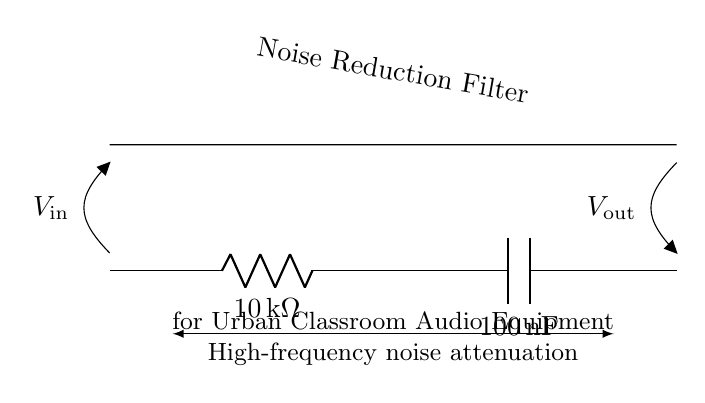What is the resistance value in the circuit? The resistance is written next to the resistor symbol and is noted as 10 kilohms in the circuit diagram.
Answer: 10 kilohms What component is labeled as C1? C1 is labeled as a capacitor, which is indicated in the diagram and has a specific capacitance value listed next to it.
Answer: Capacitor What does V_in represent in this circuit? V_in represents the input voltage; it's indicated at the starting point of the circuit where the input signal would enter.
Answer: Input voltage How does this circuit affect high-frequency noise? This circuit is designed to attenuate high-frequency noise, as shown by the label that describes the function between the resistor and capacitor components.
Answer: Attenuates high-frequency noise What is the system type represented by this circuit? The circuit type is a low-pass filter made by combining a resistor and a capacitor, which is specifically used for allowing low-frequency signals to pass while blocking higher frequencies.
Answer: Low-pass filter What happens to signals above the cutoff frequency in this filter? Signals above the cutoff frequency are significantly reduced in amplitude due to the interaction between the resistor and capacitor, which is characteristic of this type of filter.
Answer: Reduced amplitude What is the total capacitance in the circuit? The total capacitance is specified as 100 nanofarads, noted next to the capacitor symbol in the diagram.
Answer: 100 nanofarads 